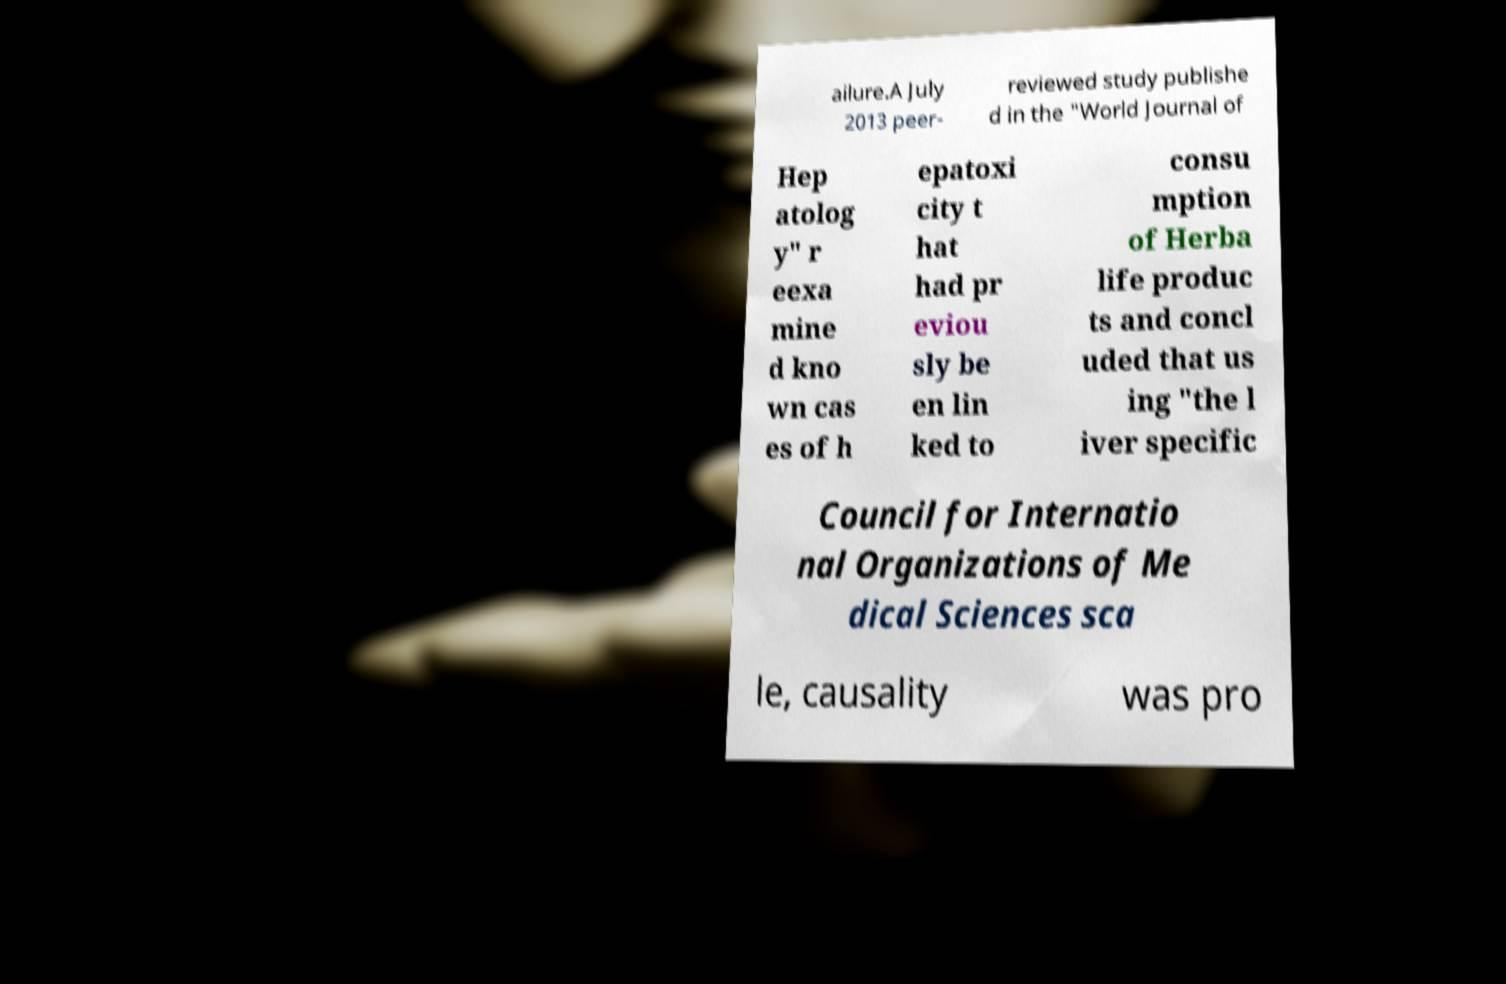Please identify and transcribe the text found in this image. ailure.A July 2013 peer- reviewed study publishe d in the "World Journal of Hep atolog y" r eexa mine d kno wn cas es of h epatoxi city t hat had pr eviou sly be en lin ked to consu mption of Herba life produc ts and concl uded that us ing "the l iver specific Council for Internatio nal Organizations of Me dical Sciences sca le, causality was pro 